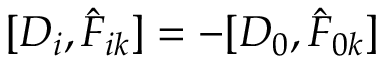Convert formula to latex. <formula><loc_0><loc_0><loc_500><loc_500>[ D _ { i } , \hat { F } _ { i k } ] = - [ D _ { 0 } , \hat { F } _ { 0 k } ]</formula> 